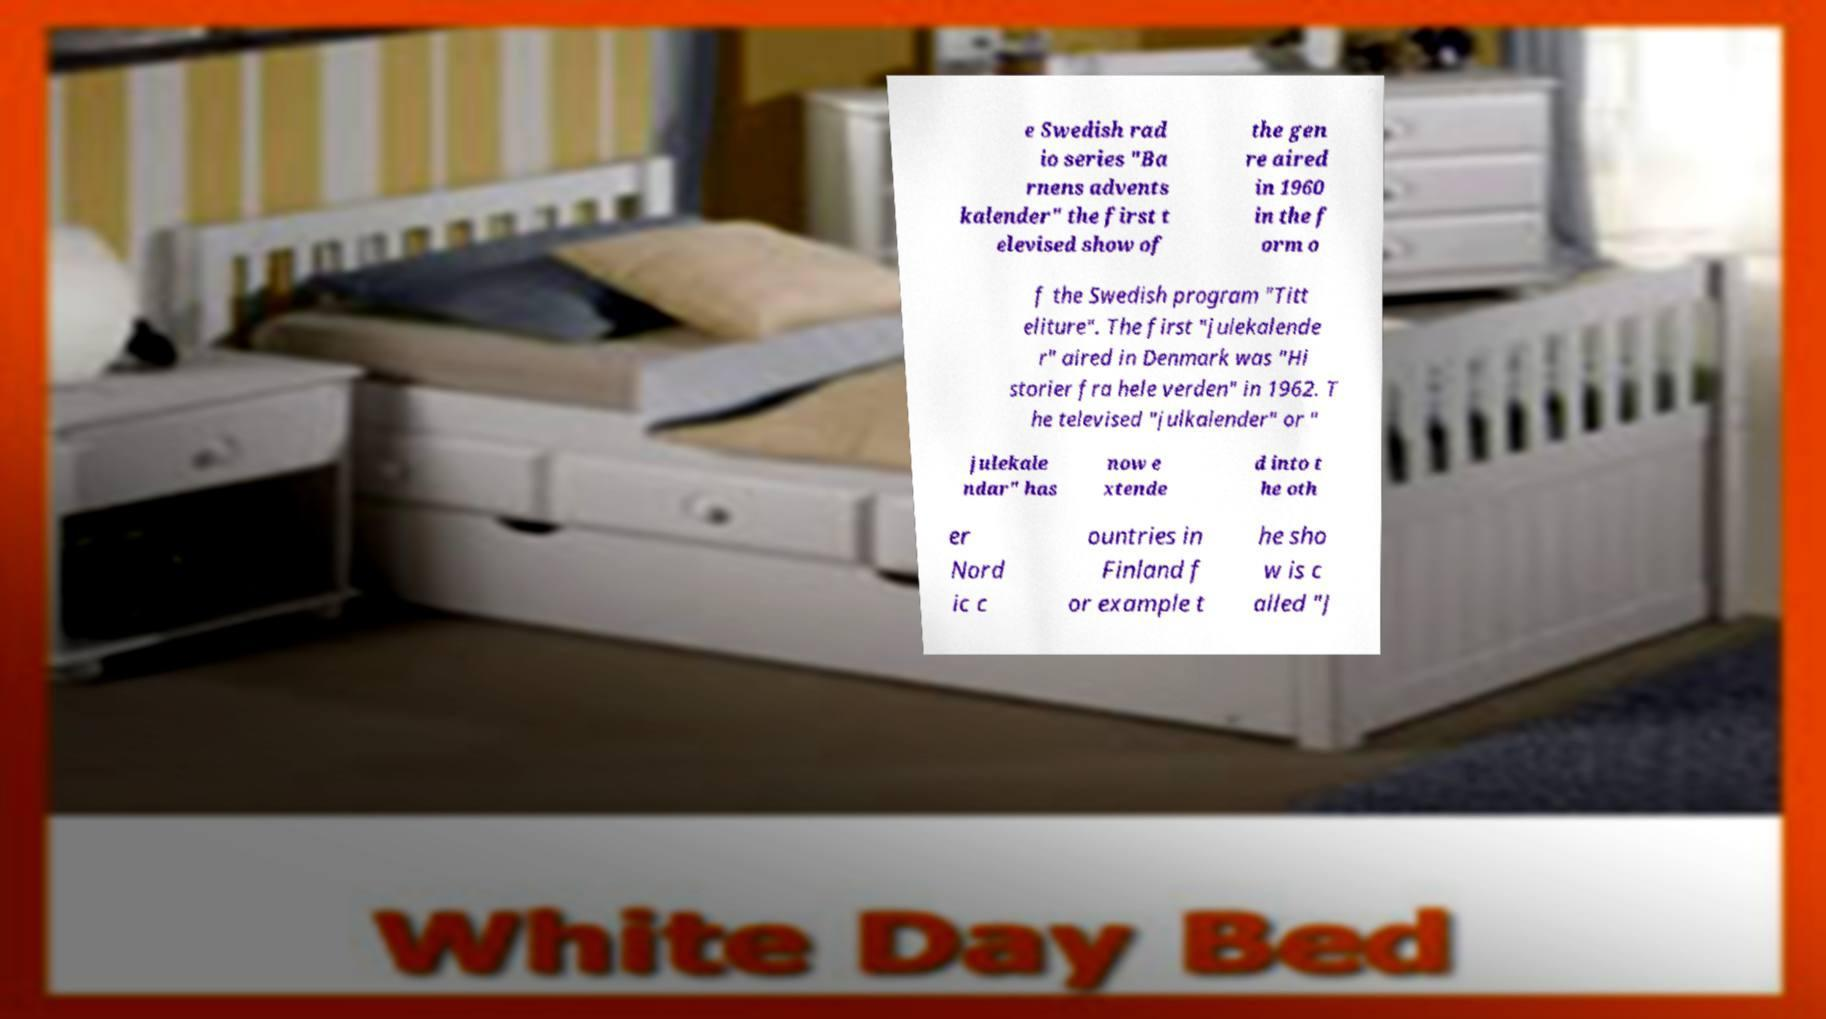For documentation purposes, I need the text within this image transcribed. Could you provide that? e Swedish rad io series "Ba rnens advents kalender" the first t elevised show of the gen re aired in 1960 in the f orm o f the Swedish program "Titt eliture". The first "julekalende r" aired in Denmark was "Hi storier fra hele verden" in 1962. T he televised "julkalender" or " julekale ndar" has now e xtende d into t he oth er Nord ic c ountries in Finland f or example t he sho w is c alled "J 